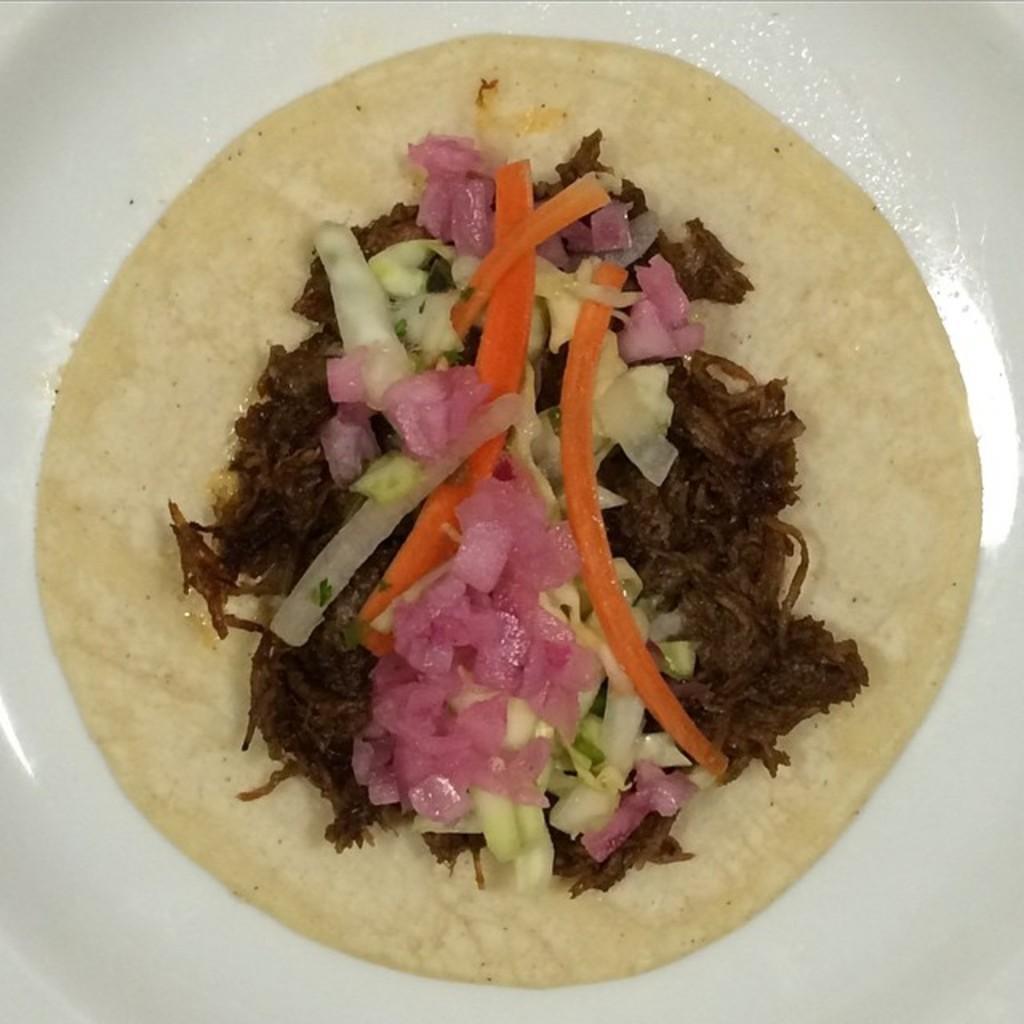Could you give a brief overview of what you see in this image? In this picture, we see a white plate containing the food item. In this food item, we see the onions, cabbage and carrot. 